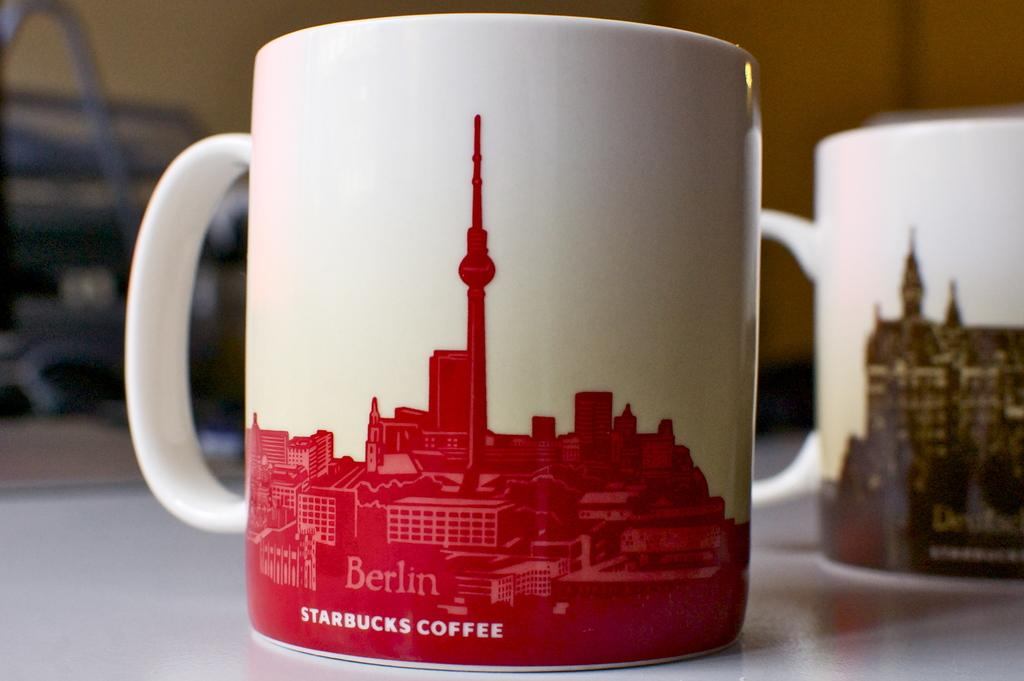<image>
Provide a brief description of the given image. Two coffee mugs, one from Starbucks, sit on a tabletop. 